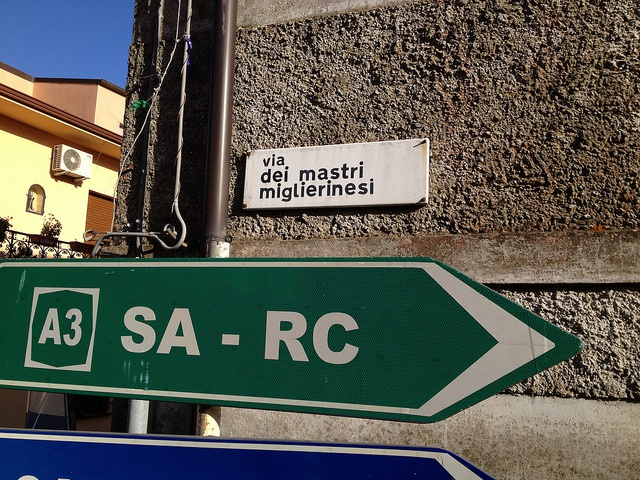Describe the objects in this image and their specific colors. I can see a potted plant in blue, black, khaki, lightyellow, and olive tones in this image. 